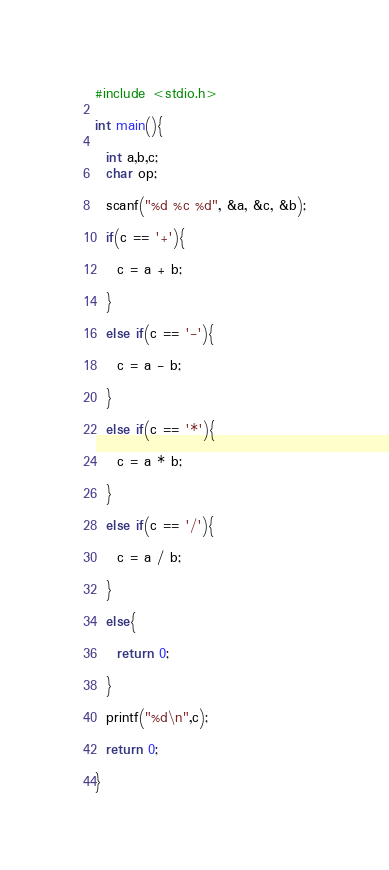Convert code to text. <code><loc_0><loc_0><loc_500><loc_500><_C_>#include <stdio.h>

int main(){

  int a,b,c;
  char op;

  scanf("%d %c %d", &a, &c, &b);

  if(c == '+'){

    c = a + b;

  }

  else if(c == '-'){

    c = a - b;

  }

  else if(c == '*'){

    c = a * b;

  }

  else if(c == '/'){

    c = a / b;

  }

  else{

    return 0;

  }

  printf("%d\n",c);

  return 0;

}</code> 